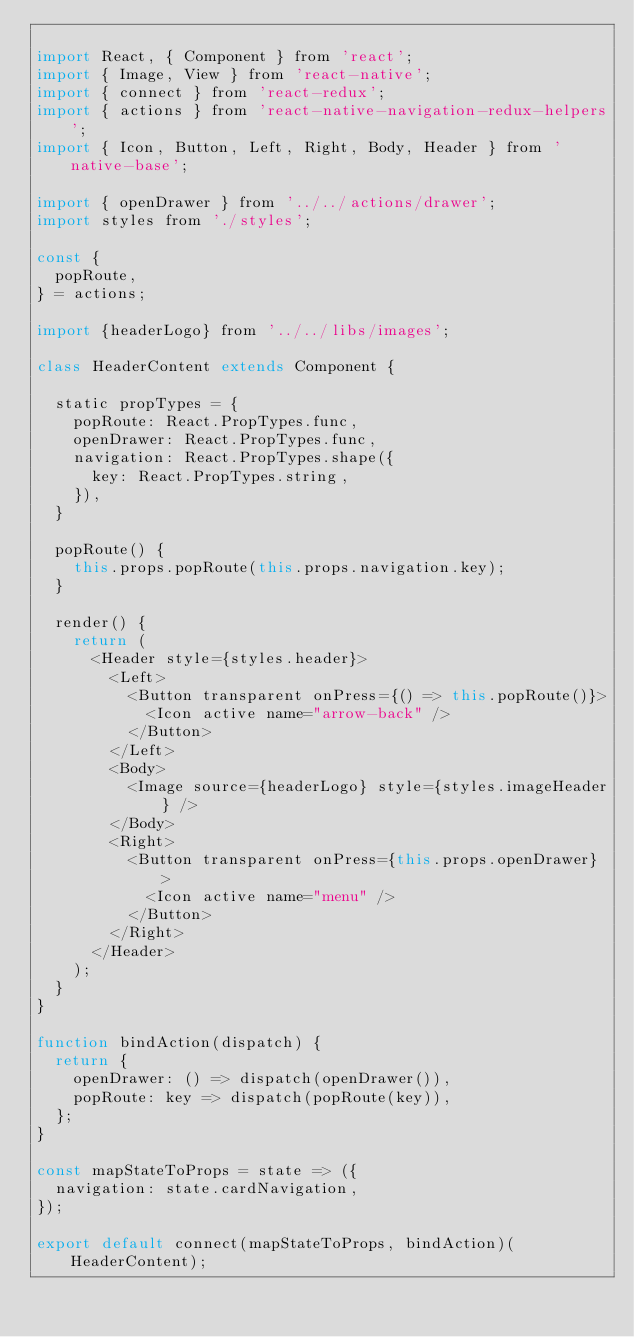Convert code to text. <code><loc_0><loc_0><loc_500><loc_500><_JavaScript_>
import React, { Component } from 'react';
import { Image, View } from 'react-native';
import { connect } from 'react-redux';
import { actions } from 'react-native-navigation-redux-helpers';
import { Icon, Button, Left, Right, Body, Header } from 'native-base';

import { openDrawer } from '../../actions/drawer';
import styles from './styles';

const {
  popRoute,
} = actions;

import {headerLogo} from '../../libs/images';

class HeaderContent extends Component {

  static propTypes = {
    popRoute: React.PropTypes.func,
    openDrawer: React.PropTypes.func,
    navigation: React.PropTypes.shape({
      key: React.PropTypes.string,
    }),
  }

  popRoute() {
    this.props.popRoute(this.props.navigation.key);
  }

  render() {
    return (
      <Header style={styles.header}>
        <Left>
          <Button transparent onPress={() => this.popRoute()}>
            <Icon active name="arrow-back" />
          </Button>
        </Left>
        <Body>
          <Image source={headerLogo} style={styles.imageHeader} />
        </Body>
        <Right>
          <Button transparent onPress={this.props.openDrawer} >
            <Icon active name="menu" />
          </Button>
        </Right>
      </Header>
    );
  }
}

function bindAction(dispatch) {
  return {
    openDrawer: () => dispatch(openDrawer()),
    popRoute: key => dispatch(popRoute(key)),
  };
}

const mapStateToProps = state => ({
  navigation: state.cardNavigation,
});

export default connect(mapStateToProps, bindAction)(HeaderContent);
</code> 